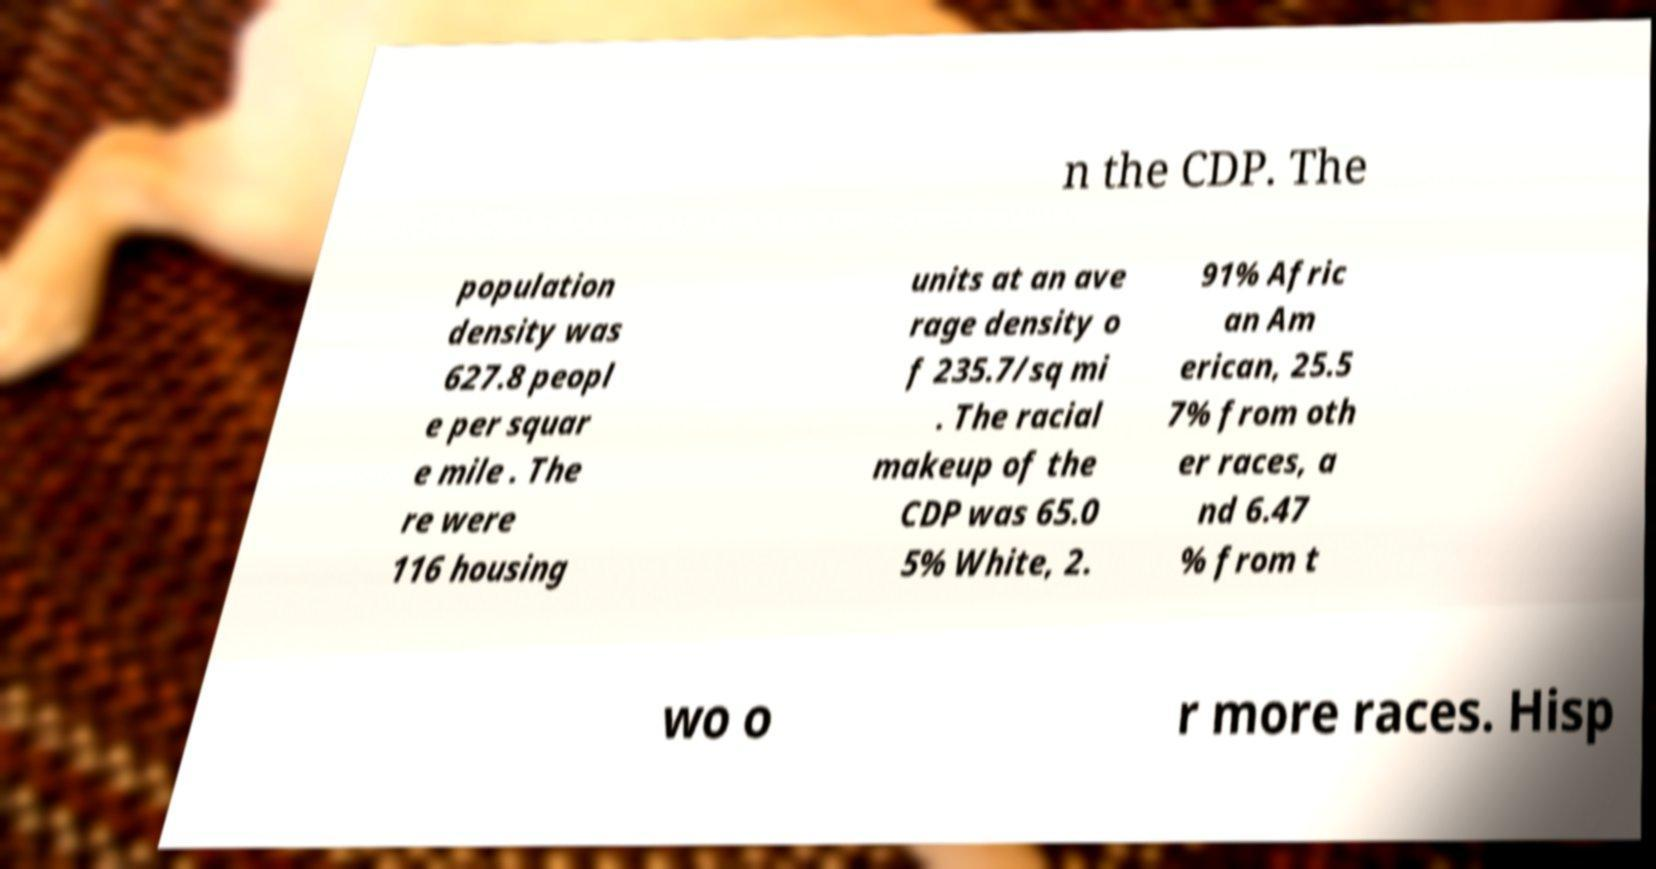I need the written content from this picture converted into text. Can you do that? n the CDP. The population density was 627.8 peopl e per squar e mile . The re were 116 housing units at an ave rage density o f 235.7/sq mi . The racial makeup of the CDP was 65.0 5% White, 2. 91% Afric an Am erican, 25.5 7% from oth er races, a nd 6.47 % from t wo o r more races. Hisp 